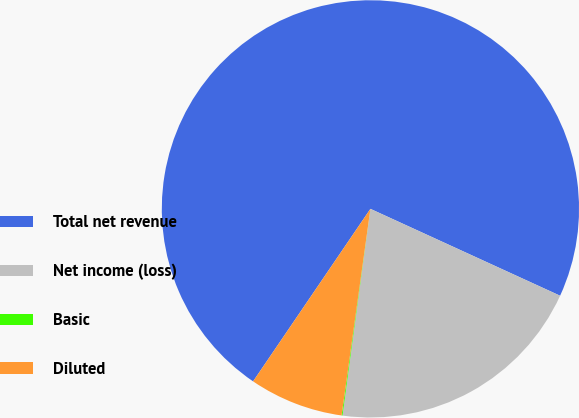Convert chart. <chart><loc_0><loc_0><loc_500><loc_500><pie_chart><fcel>Total net revenue<fcel>Net income (loss)<fcel>Basic<fcel>Diluted<nl><fcel>72.33%<fcel>20.3%<fcel>0.07%<fcel>7.3%<nl></chart> 